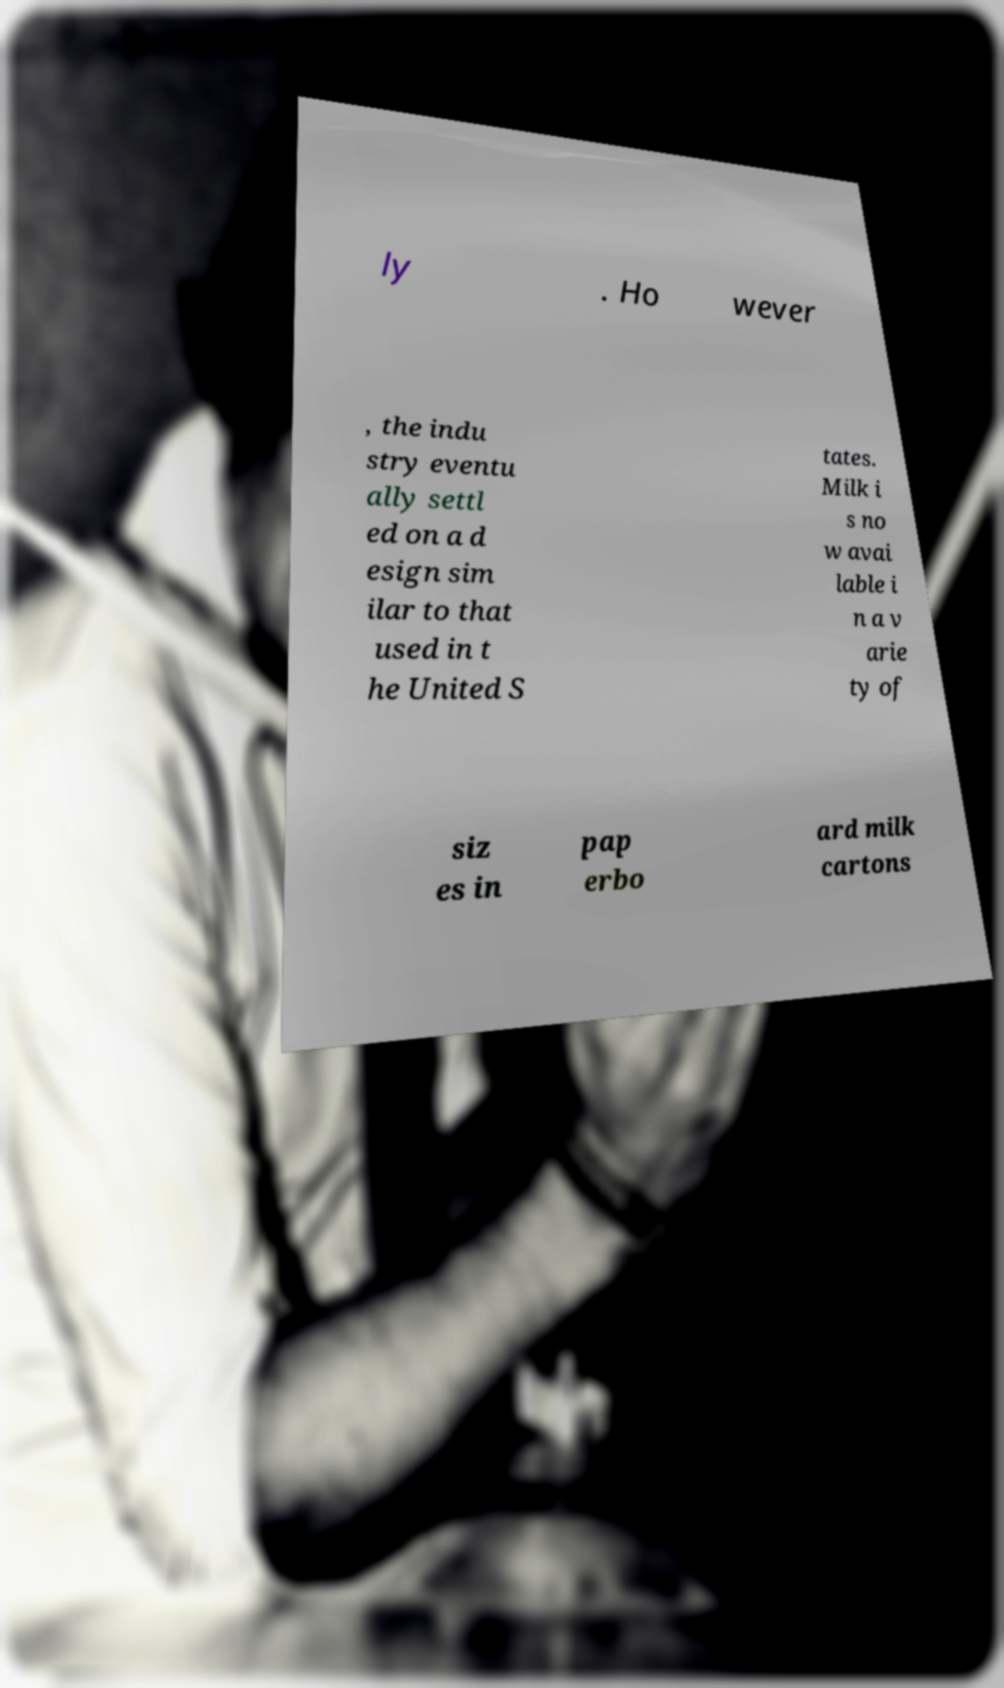Please read and relay the text visible in this image. What does it say? ly . Ho wever , the indu stry eventu ally settl ed on a d esign sim ilar to that used in t he United S tates. Milk i s no w avai lable i n a v arie ty of siz es in pap erbo ard milk cartons 